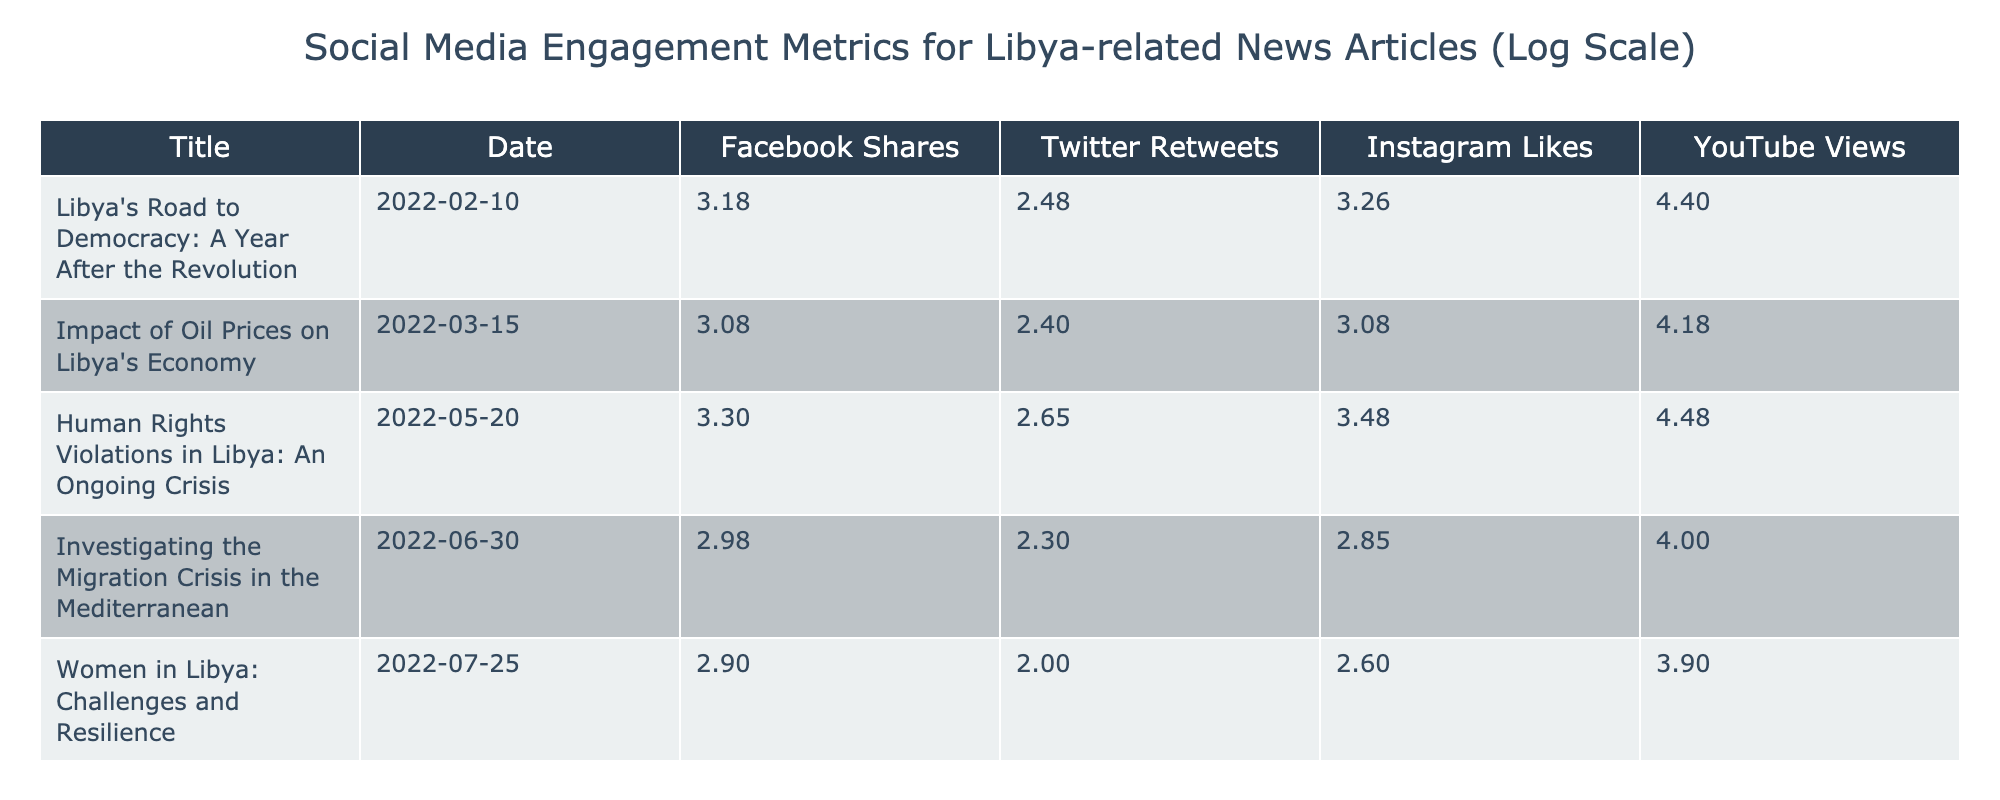What is the highest number of Facebook shares recorded in the table? By examining the "Facebook Shares" column, the highest value is found in the row titled "Human Rights Violations in Libya: An Ongoing Crisis," which shows 2000 shares.
Answer: 2000 What is the average number of Twitter retweets for articles in this table? To find the average, sum the values of Twitter retweets: (300 + 250 + 450 + 200 + 100 + 350) = 1650. Then divide by the number of articles (6): 1650/6 = 275.
Answer: 275 Is there an article with more YouTube views than Instagram likes? Comparing the "YouTube Views" and "Instagram Likes" for each article, it is clear that "Human Rights Violations in Libya: An Ongoing Crisis" has 30000 views, which is indeed greater than 3000 likes. Thus, the answer is yes.
Answer: Yes Which article has the lowest number of Instagram likes? Looking at the "Instagram Likes" column, the article with the lowest value is "Women in Libya: Challenges and Resilience" with 400 likes.
Answer: 400 How many total social media engagements (sum of Facebook shares, Twitter retweets, Instagram likes, and YouTube views) did the article "International Relations: Libya's Role in the Arab World" receive? For the article "International Relations: Libya's Role in the Arab World," we add: 1700 (Facebook) + 350 (Twitter) + 2200 (Instagram) + 28000 (YouTube) = 32700 total engagements.
Answer: 32700 Does the article "Investigating the Migration Crisis in the Mediterranean" have more Facebook shares than "Impact of Oil Prices on Libya's Economy"? The Facebook shares for "Investigating the Migration Crisis in the Mediterranean" is 950, while for "Impact of Oil Prices on Libya's Economy," it is 1200. Since 950 is less than 1200, the answer is no.
Answer: No What is the total number of Instagram likes for all articles combined? To find the total, sum the Instagram likes: 1800 + 1200 + 3000 + 700 + 400 + 2200 = 10,300 total Instagram likes for all articles.
Answer: 10300 What is the difference between the maximum and minimum number of YouTube views in the table? The maximum number of YouTube views is 30000 (for "Human Rights Violations in Libya: An Ongoing Crisis") and the minimum is 10000 (for "Investigating the Migration Crisis in the Mediterranean"). The difference is 30000 - 10000 = 20000.
Answer: 20000 